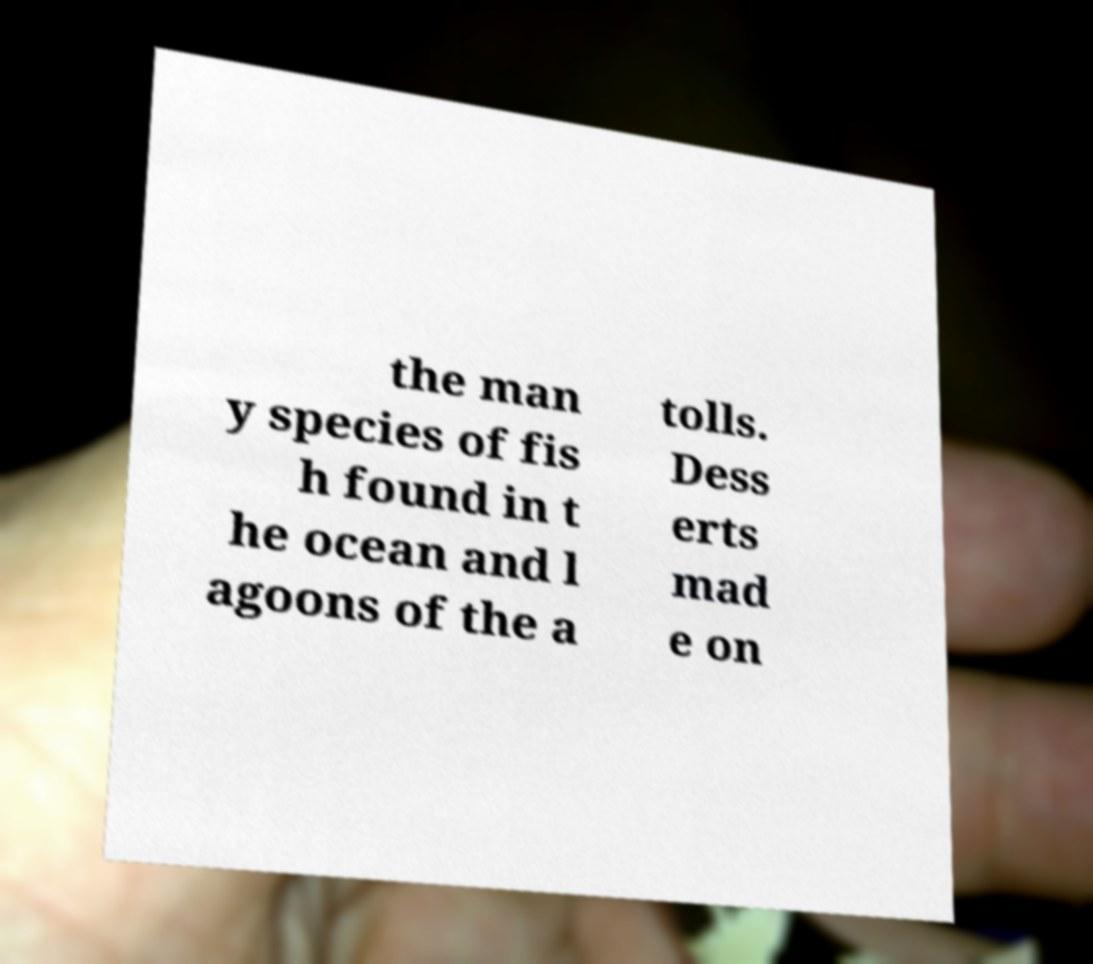I need the written content from this picture converted into text. Can you do that? the man y species of fis h found in t he ocean and l agoons of the a tolls. Dess erts mad e on 